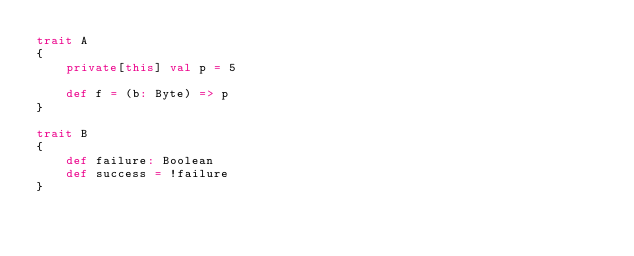Convert code to text. <code><loc_0><loc_0><loc_500><loc_500><_Scala_>trait A
{
	private[this] val p = 5

	def f = (b: Byte) => p
}

trait B
{
	def failure: Boolean
	def success = !failure
}

</code> 